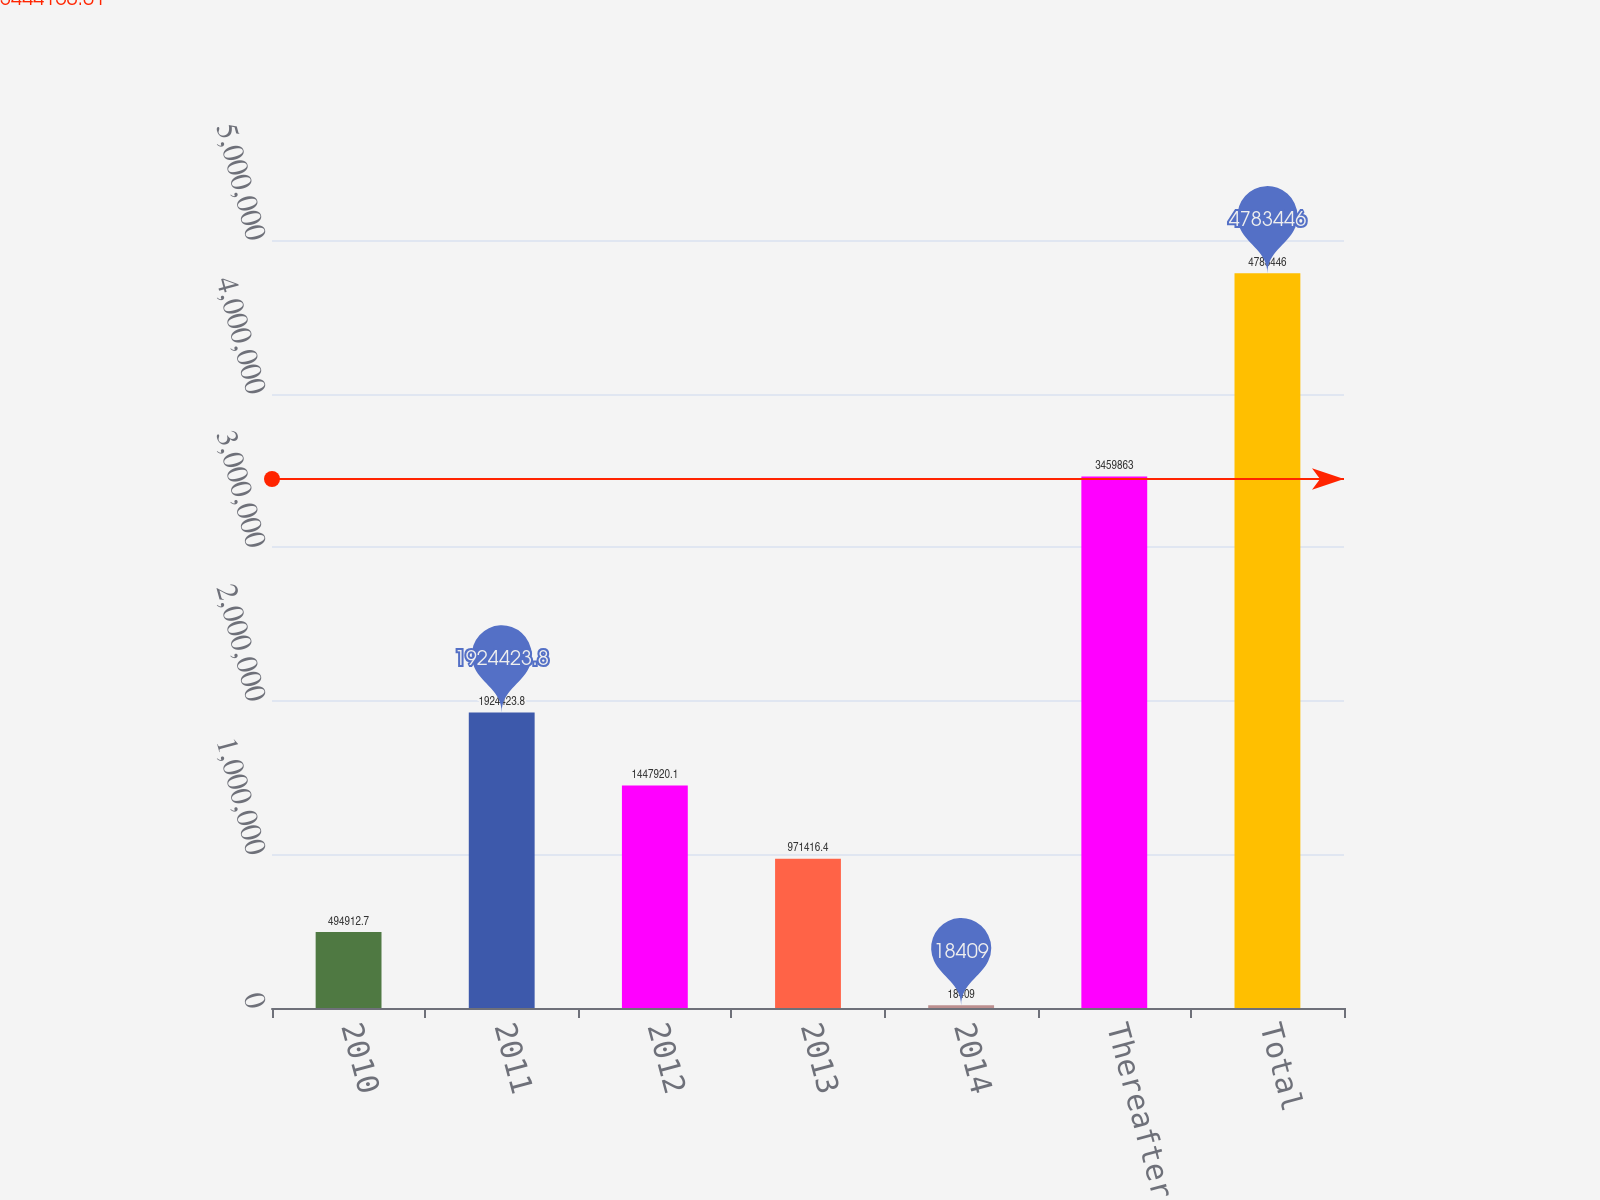Convert chart. <chart><loc_0><loc_0><loc_500><loc_500><bar_chart><fcel>2010<fcel>2011<fcel>2012<fcel>2013<fcel>2014<fcel>Thereafter<fcel>Total<nl><fcel>494913<fcel>1.92442e+06<fcel>1.44792e+06<fcel>971416<fcel>18409<fcel>3.45986e+06<fcel>4.78345e+06<nl></chart> 